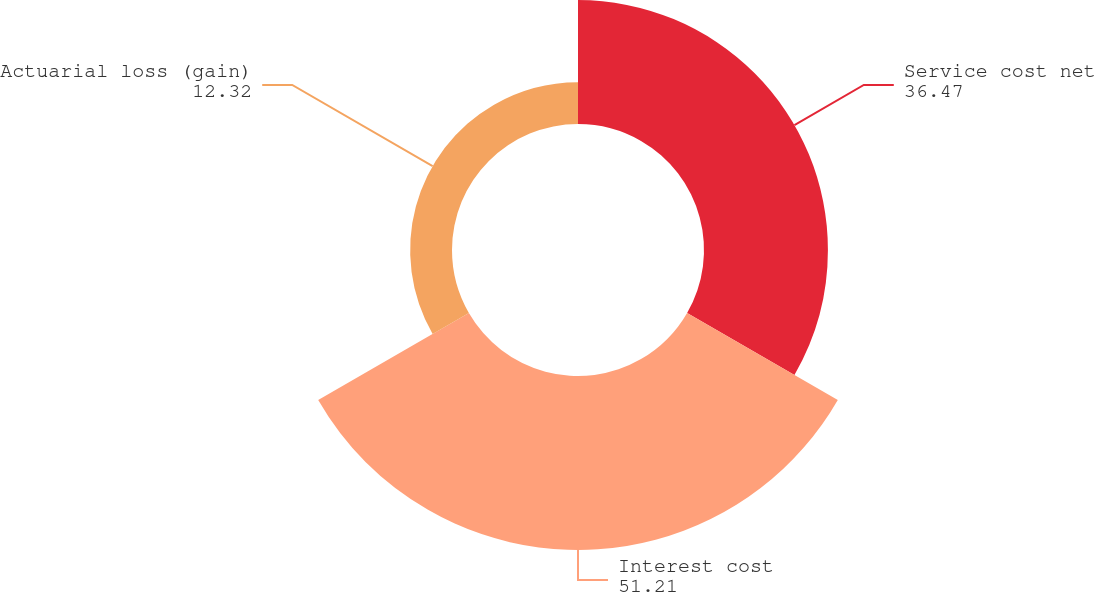Convert chart. <chart><loc_0><loc_0><loc_500><loc_500><pie_chart><fcel>Service cost net<fcel>Interest cost<fcel>Actuarial loss (gain)<nl><fcel>36.47%<fcel>51.21%<fcel>12.32%<nl></chart> 